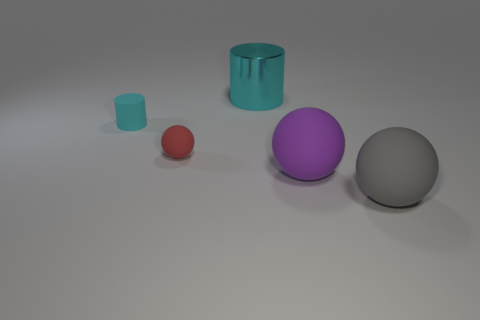There is a cyan object that is the same size as the gray rubber thing; what material is it?
Provide a short and direct response. Metal. How big is the object that is both right of the small ball and behind the red rubber ball?
Give a very brief answer. Large. What color is the sphere that is in front of the red matte ball and behind the big gray thing?
Offer a terse response. Purple. Are there fewer large cyan objects that are in front of the tiny rubber sphere than cyan things that are in front of the large cylinder?
Provide a succinct answer. Yes. What number of small red rubber objects are the same shape as the gray thing?
Make the answer very short. 1. There is a purple sphere that is made of the same material as the big gray sphere; what size is it?
Keep it short and to the point. Large. There is a big matte sphere behind the rubber thing on the right side of the purple thing; what is its color?
Provide a succinct answer. Purple. There is a red object; is its shape the same as the big rubber object that is in front of the big purple thing?
Provide a succinct answer. Yes. How many other purple things are the same size as the metal thing?
Give a very brief answer. 1. There is another cyan object that is the same shape as the tiny cyan matte object; what is it made of?
Keep it short and to the point. Metal. 